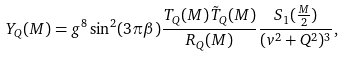Convert formula to latex. <formula><loc_0><loc_0><loc_500><loc_500>Y _ { Q } ( M ) = g ^ { 8 } \sin ^ { 2 } ( 3 \pi \beta ) \frac { T _ { Q } ( M ) \tilde { T } _ { Q } ( M ) } { R _ { Q } ( M ) } \frac { S _ { 1 } ( \frac { M } { 2 } ) } { ( v ^ { 2 } + Q ^ { 2 } ) ^ { 3 } } ,</formula> 